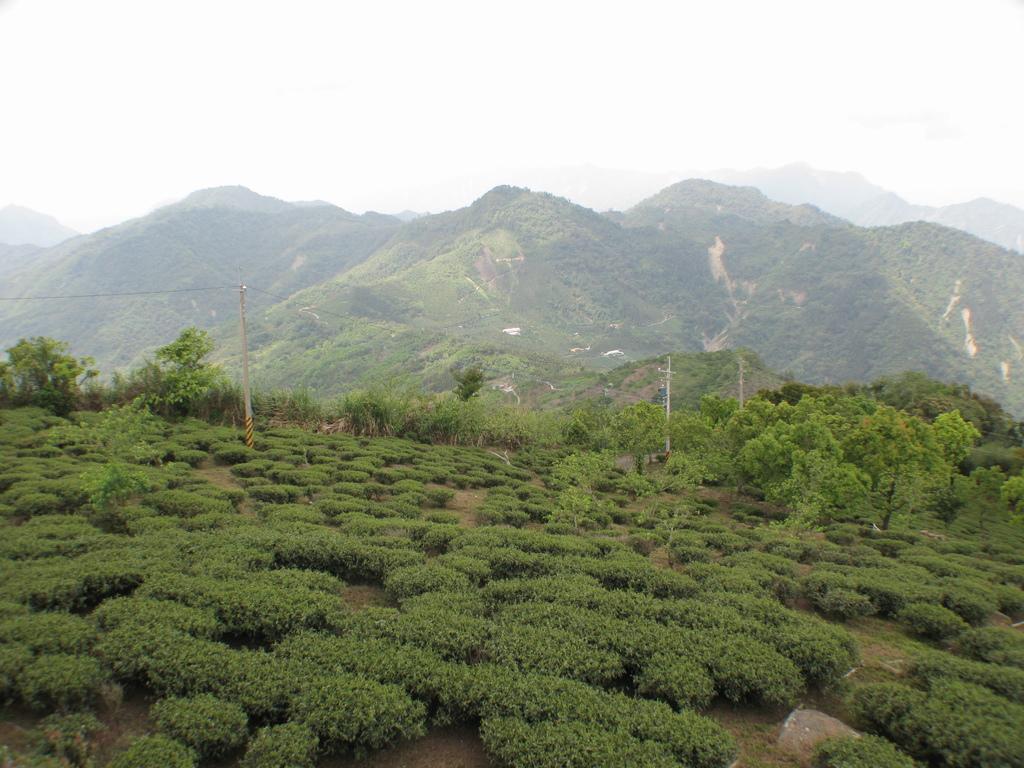Please provide a concise description of this image. There is a tea plantation. In the back there are electric poles with wires and trees. In the background there are hills and sky. 